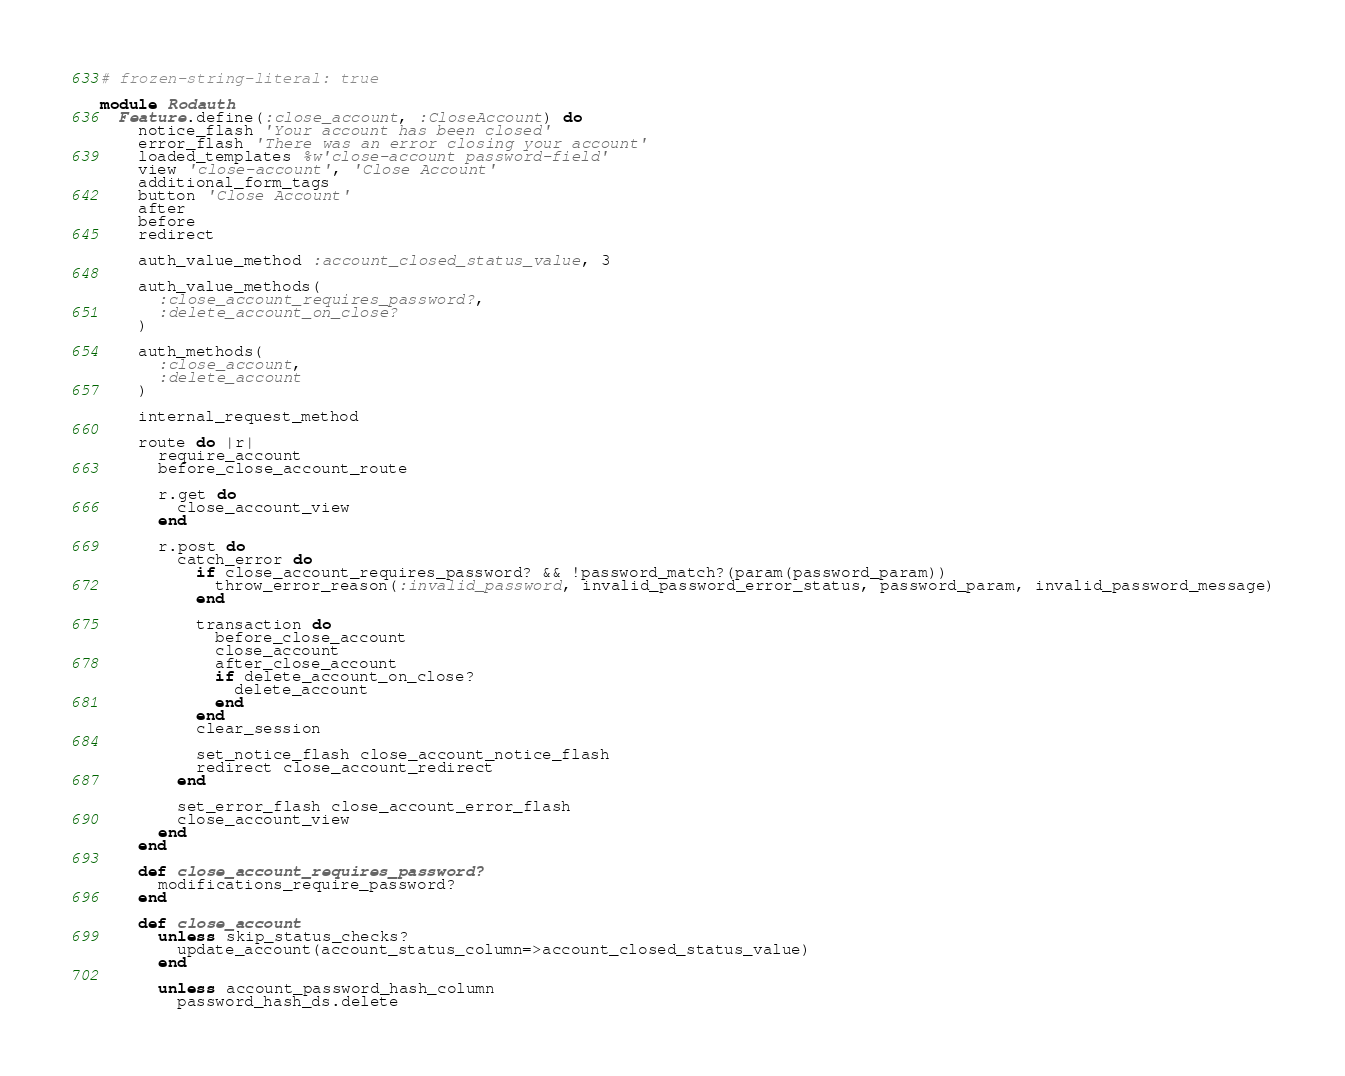Convert code to text. <code><loc_0><loc_0><loc_500><loc_500><_Ruby_># frozen-string-literal: true

module Rodauth
  Feature.define(:close_account, :CloseAccount) do
    notice_flash 'Your account has been closed'
    error_flash 'There was an error closing your account'
    loaded_templates %w'close-account password-field'
    view 'close-account', 'Close Account'
    additional_form_tags
    button 'Close Account'
    after
    before
    redirect

    auth_value_method :account_closed_status_value, 3

    auth_value_methods(
      :close_account_requires_password?,
      :delete_account_on_close?
    )

    auth_methods(
      :close_account,
      :delete_account
    )

    internal_request_method

    route do |r|
      require_account
      before_close_account_route

      r.get do
        close_account_view
      end

      r.post do
        catch_error do
          if close_account_requires_password? && !password_match?(param(password_param))
            throw_error_reason(:invalid_password, invalid_password_error_status, password_param, invalid_password_message)
          end

          transaction do
            before_close_account
            close_account
            after_close_account
            if delete_account_on_close?
              delete_account
            end
          end
          clear_session

          set_notice_flash close_account_notice_flash
          redirect close_account_redirect
        end

        set_error_flash close_account_error_flash
        close_account_view
      end
    end

    def close_account_requires_password?
      modifications_require_password?
    end

    def close_account
      unless skip_status_checks?
        update_account(account_status_column=>account_closed_status_value)
      end

      unless account_password_hash_column
        password_hash_ds.delete</code> 